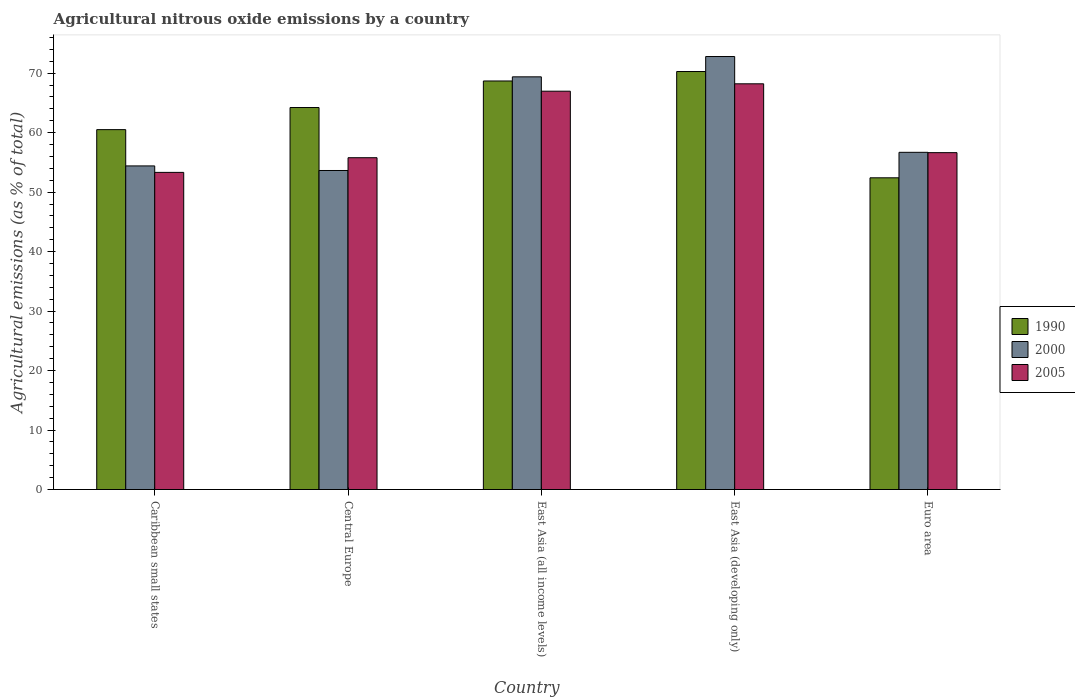How many different coloured bars are there?
Give a very brief answer. 3. Are the number of bars on each tick of the X-axis equal?
Keep it short and to the point. Yes. How many bars are there on the 5th tick from the left?
Give a very brief answer. 3. How many bars are there on the 5th tick from the right?
Give a very brief answer. 3. What is the label of the 2nd group of bars from the left?
Provide a short and direct response. Central Europe. What is the amount of agricultural nitrous oxide emitted in 2000 in East Asia (developing only)?
Your answer should be compact. 72.8. Across all countries, what is the maximum amount of agricultural nitrous oxide emitted in 1990?
Offer a terse response. 70.28. Across all countries, what is the minimum amount of agricultural nitrous oxide emitted in 2000?
Offer a very short reply. 53.64. In which country was the amount of agricultural nitrous oxide emitted in 2000 maximum?
Your response must be concise. East Asia (developing only). In which country was the amount of agricultural nitrous oxide emitted in 2005 minimum?
Make the answer very short. Caribbean small states. What is the total amount of agricultural nitrous oxide emitted in 2000 in the graph?
Your answer should be very brief. 306.92. What is the difference between the amount of agricultural nitrous oxide emitted in 2000 in Caribbean small states and that in Euro area?
Your answer should be compact. -2.28. What is the difference between the amount of agricultural nitrous oxide emitted in 1990 in East Asia (developing only) and the amount of agricultural nitrous oxide emitted in 2005 in Euro area?
Your answer should be very brief. 13.64. What is the average amount of agricultural nitrous oxide emitted in 2000 per country?
Offer a terse response. 61.38. What is the difference between the amount of agricultural nitrous oxide emitted of/in 1990 and amount of agricultural nitrous oxide emitted of/in 2005 in Caribbean small states?
Your answer should be very brief. 7.19. What is the ratio of the amount of agricultural nitrous oxide emitted in 2000 in Central Europe to that in East Asia (developing only)?
Your answer should be compact. 0.74. What is the difference between the highest and the second highest amount of agricultural nitrous oxide emitted in 2005?
Provide a succinct answer. -10.33. What is the difference between the highest and the lowest amount of agricultural nitrous oxide emitted in 2005?
Provide a succinct answer. 14.89. In how many countries, is the amount of agricultural nitrous oxide emitted in 2000 greater than the average amount of agricultural nitrous oxide emitted in 2000 taken over all countries?
Your answer should be very brief. 2. Is the sum of the amount of agricultural nitrous oxide emitted in 2000 in Central Europe and East Asia (all income levels) greater than the maximum amount of agricultural nitrous oxide emitted in 2005 across all countries?
Your answer should be compact. Yes. What does the 2nd bar from the left in East Asia (developing only) represents?
Your answer should be compact. 2000. Is it the case that in every country, the sum of the amount of agricultural nitrous oxide emitted in 2005 and amount of agricultural nitrous oxide emitted in 1990 is greater than the amount of agricultural nitrous oxide emitted in 2000?
Provide a succinct answer. Yes. How many countries are there in the graph?
Keep it short and to the point. 5. What is the title of the graph?
Offer a terse response. Agricultural nitrous oxide emissions by a country. What is the label or title of the X-axis?
Your response must be concise. Country. What is the label or title of the Y-axis?
Offer a terse response. Agricultural emissions (as % of total). What is the Agricultural emissions (as % of total) in 1990 in Caribbean small states?
Make the answer very short. 60.51. What is the Agricultural emissions (as % of total) of 2000 in Caribbean small states?
Ensure brevity in your answer.  54.41. What is the Agricultural emissions (as % of total) in 2005 in Caribbean small states?
Give a very brief answer. 53.32. What is the Agricultural emissions (as % of total) in 1990 in Central Europe?
Offer a very short reply. 64.23. What is the Agricultural emissions (as % of total) in 2000 in Central Europe?
Ensure brevity in your answer.  53.64. What is the Agricultural emissions (as % of total) of 2005 in Central Europe?
Make the answer very short. 55.79. What is the Agricultural emissions (as % of total) of 1990 in East Asia (all income levels)?
Make the answer very short. 68.69. What is the Agricultural emissions (as % of total) in 2000 in East Asia (all income levels)?
Your answer should be very brief. 69.38. What is the Agricultural emissions (as % of total) of 2005 in East Asia (all income levels)?
Provide a succinct answer. 66.97. What is the Agricultural emissions (as % of total) in 1990 in East Asia (developing only)?
Make the answer very short. 70.28. What is the Agricultural emissions (as % of total) of 2000 in East Asia (developing only)?
Your response must be concise. 72.8. What is the Agricultural emissions (as % of total) in 2005 in East Asia (developing only)?
Your response must be concise. 68.21. What is the Agricultural emissions (as % of total) of 1990 in Euro area?
Your response must be concise. 52.41. What is the Agricultural emissions (as % of total) of 2000 in Euro area?
Give a very brief answer. 56.69. What is the Agricultural emissions (as % of total) in 2005 in Euro area?
Your answer should be very brief. 56.64. Across all countries, what is the maximum Agricultural emissions (as % of total) of 1990?
Offer a very short reply. 70.28. Across all countries, what is the maximum Agricultural emissions (as % of total) in 2000?
Offer a terse response. 72.8. Across all countries, what is the maximum Agricultural emissions (as % of total) in 2005?
Make the answer very short. 68.21. Across all countries, what is the minimum Agricultural emissions (as % of total) of 1990?
Your response must be concise. 52.41. Across all countries, what is the minimum Agricultural emissions (as % of total) of 2000?
Make the answer very short. 53.64. Across all countries, what is the minimum Agricultural emissions (as % of total) in 2005?
Ensure brevity in your answer.  53.32. What is the total Agricultural emissions (as % of total) of 1990 in the graph?
Give a very brief answer. 316.1. What is the total Agricultural emissions (as % of total) of 2000 in the graph?
Offer a very short reply. 306.92. What is the total Agricultural emissions (as % of total) of 2005 in the graph?
Offer a terse response. 300.92. What is the difference between the Agricultural emissions (as % of total) in 1990 in Caribbean small states and that in Central Europe?
Your answer should be very brief. -3.72. What is the difference between the Agricultural emissions (as % of total) of 2000 in Caribbean small states and that in Central Europe?
Ensure brevity in your answer.  0.77. What is the difference between the Agricultural emissions (as % of total) of 2005 in Caribbean small states and that in Central Europe?
Ensure brevity in your answer.  -2.47. What is the difference between the Agricultural emissions (as % of total) of 1990 in Caribbean small states and that in East Asia (all income levels)?
Give a very brief answer. -8.18. What is the difference between the Agricultural emissions (as % of total) in 2000 in Caribbean small states and that in East Asia (all income levels)?
Your answer should be compact. -14.97. What is the difference between the Agricultural emissions (as % of total) in 2005 in Caribbean small states and that in East Asia (all income levels)?
Your answer should be very brief. -13.65. What is the difference between the Agricultural emissions (as % of total) of 1990 in Caribbean small states and that in East Asia (developing only)?
Your response must be concise. -9.77. What is the difference between the Agricultural emissions (as % of total) in 2000 in Caribbean small states and that in East Asia (developing only)?
Your answer should be very brief. -18.39. What is the difference between the Agricultural emissions (as % of total) of 2005 in Caribbean small states and that in East Asia (developing only)?
Your response must be concise. -14.89. What is the difference between the Agricultural emissions (as % of total) in 1990 in Caribbean small states and that in Euro area?
Keep it short and to the point. 8.1. What is the difference between the Agricultural emissions (as % of total) in 2000 in Caribbean small states and that in Euro area?
Offer a very short reply. -2.28. What is the difference between the Agricultural emissions (as % of total) in 2005 in Caribbean small states and that in Euro area?
Ensure brevity in your answer.  -3.32. What is the difference between the Agricultural emissions (as % of total) of 1990 in Central Europe and that in East Asia (all income levels)?
Provide a succinct answer. -4.46. What is the difference between the Agricultural emissions (as % of total) in 2000 in Central Europe and that in East Asia (all income levels)?
Provide a short and direct response. -15.75. What is the difference between the Agricultural emissions (as % of total) in 2005 in Central Europe and that in East Asia (all income levels)?
Provide a short and direct response. -11.18. What is the difference between the Agricultural emissions (as % of total) of 1990 in Central Europe and that in East Asia (developing only)?
Offer a terse response. -6.05. What is the difference between the Agricultural emissions (as % of total) in 2000 in Central Europe and that in East Asia (developing only)?
Offer a terse response. -19.16. What is the difference between the Agricultural emissions (as % of total) of 2005 in Central Europe and that in East Asia (developing only)?
Your response must be concise. -12.43. What is the difference between the Agricultural emissions (as % of total) of 1990 in Central Europe and that in Euro area?
Offer a very short reply. 11.82. What is the difference between the Agricultural emissions (as % of total) of 2000 in Central Europe and that in Euro area?
Your response must be concise. -3.06. What is the difference between the Agricultural emissions (as % of total) of 2005 in Central Europe and that in Euro area?
Provide a short and direct response. -0.85. What is the difference between the Agricultural emissions (as % of total) in 1990 in East Asia (all income levels) and that in East Asia (developing only)?
Provide a short and direct response. -1.59. What is the difference between the Agricultural emissions (as % of total) of 2000 in East Asia (all income levels) and that in East Asia (developing only)?
Provide a succinct answer. -3.42. What is the difference between the Agricultural emissions (as % of total) of 2005 in East Asia (all income levels) and that in East Asia (developing only)?
Your answer should be very brief. -1.24. What is the difference between the Agricultural emissions (as % of total) of 1990 in East Asia (all income levels) and that in Euro area?
Give a very brief answer. 16.28. What is the difference between the Agricultural emissions (as % of total) of 2000 in East Asia (all income levels) and that in Euro area?
Provide a succinct answer. 12.69. What is the difference between the Agricultural emissions (as % of total) in 2005 in East Asia (all income levels) and that in Euro area?
Offer a very short reply. 10.33. What is the difference between the Agricultural emissions (as % of total) of 1990 in East Asia (developing only) and that in Euro area?
Your answer should be very brief. 17.87. What is the difference between the Agricultural emissions (as % of total) in 2000 in East Asia (developing only) and that in Euro area?
Give a very brief answer. 16.11. What is the difference between the Agricultural emissions (as % of total) in 2005 in East Asia (developing only) and that in Euro area?
Keep it short and to the point. 11.57. What is the difference between the Agricultural emissions (as % of total) of 1990 in Caribbean small states and the Agricultural emissions (as % of total) of 2000 in Central Europe?
Provide a succinct answer. 6.87. What is the difference between the Agricultural emissions (as % of total) of 1990 in Caribbean small states and the Agricultural emissions (as % of total) of 2005 in Central Europe?
Make the answer very short. 4.72. What is the difference between the Agricultural emissions (as % of total) in 2000 in Caribbean small states and the Agricultural emissions (as % of total) in 2005 in Central Europe?
Your answer should be compact. -1.38. What is the difference between the Agricultural emissions (as % of total) of 1990 in Caribbean small states and the Agricultural emissions (as % of total) of 2000 in East Asia (all income levels)?
Provide a short and direct response. -8.88. What is the difference between the Agricultural emissions (as % of total) in 1990 in Caribbean small states and the Agricultural emissions (as % of total) in 2005 in East Asia (all income levels)?
Make the answer very short. -6.46. What is the difference between the Agricultural emissions (as % of total) of 2000 in Caribbean small states and the Agricultural emissions (as % of total) of 2005 in East Asia (all income levels)?
Offer a very short reply. -12.56. What is the difference between the Agricultural emissions (as % of total) of 1990 in Caribbean small states and the Agricultural emissions (as % of total) of 2000 in East Asia (developing only)?
Offer a very short reply. -12.29. What is the difference between the Agricultural emissions (as % of total) of 1990 in Caribbean small states and the Agricultural emissions (as % of total) of 2005 in East Asia (developing only)?
Your answer should be compact. -7.71. What is the difference between the Agricultural emissions (as % of total) in 2000 in Caribbean small states and the Agricultural emissions (as % of total) in 2005 in East Asia (developing only)?
Your answer should be compact. -13.8. What is the difference between the Agricultural emissions (as % of total) in 1990 in Caribbean small states and the Agricultural emissions (as % of total) in 2000 in Euro area?
Your answer should be compact. 3.81. What is the difference between the Agricultural emissions (as % of total) in 1990 in Caribbean small states and the Agricultural emissions (as % of total) in 2005 in Euro area?
Offer a very short reply. 3.87. What is the difference between the Agricultural emissions (as % of total) in 2000 in Caribbean small states and the Agricultural emissions (as % of total) in 2005 in Euro area?
Offer a very short reply. -2.23. What is the difference between the Agricultural emissions (as % of total) of 1990 in Central Europe and the Agricultural emissions (as % of total) of 2000 in East Asia (all income levels)?
Ensure brevity in your answer.  -5.16. What is the difference between the Agricultural emissions (as % of total) of 1990 in Central Europe and the Agricultural emissions (as % of total) of 2005 in East Asia (all income levels)?
Offer a very short reply. -2.74. What is the difference between the Agricultural emissions (as % of total) of 2000 in Central Europe and the Agricultural emissions (as % of total) of 2005 in East Asia (all income levels)?
Offer a terse response. -13.33. What is the difference between the Agricultural emissions (as % of total) of 1990 in Central Europe and the Agricultural emissions (as % of total) of 2000 in East Asia (developing only)?
Keep it short and to the point. -8.57. What is the difference between the Agricultural emissions (as % of total) in 1990 in Central Europe and the Agricultural emissions (as % of total) in 2005 in East Asia (developing only)?
Your response must be concise. -3.99. What is the difference between the Agricultural emissions (as % of total) of 2000 in Central Europe and the Agricultural emissions (as % of total) of 2005 in East Asia (developing only)?
Make the answer very short. -14.57. What is the difference between the Agricultural emissions (as % of total) in 1990 in Central Europe and the Agricultural emissions (as % of total) in 2000 in Euro area?
Offer a terse response. 7.53. What is the difference between the Agricultural emissions (as % of total) of 1990 in Central Europe and the Agricultural emissions (as % of total) of 2005 in Euro area?
Provide a short and direct response. 7.59. What is the difference between the Agricultural emissions (as % of total) in 2000 in Central Europe and the Agricultural emissions (as % of total) in 2005 in Euro area?
Your answer should be very brief. -3. What is the difference between the Agricultural emissions (as % of total) in 1990 in East Asia (all income levels) and the Agricultural emissions (as % of total) in 2000 in East Asia (developing only)?
Provide a succinct answer. -4.11. What is the difference between the Agricultural emissions (as % of total) of 1990 in East Asia (all income levels) and the Agricultural emissions (as % of total) of 2005 in East Asia (developing only)?
Offer a very short reply. 0.48. What is the difference between the Agricultural emissions (as % of total) of 2000 in East Asia (all income levels) and the Agricultural emissions (as % of total) of 2005 in East Asia (developing only)?
Give a very brief answer. 1.17. What is the difference between the Agricultural emissions (as % of total) of 1990 in East Asia (all income levels) and the Agricultural emissions (as % of total) of 2000 in Euro area?
Provide a short and direct response. 11.99. What is the difference between the Agricultural emissions (as % of total) of 1990 in East Asia (all income levels) and the Agricultural emissions (as % of total) of 2005 in Euro area?
Make the answer very short. 12.05. What is the difference between the Agricultural emissions (as % of total) of 2000 in East Asia (all income levels) and the Agricultural emissions (as % of total) of 2005 in Euro area?
Your answer should be compact. 12.74. What is the difference between the Agricultural emissions (as % of total) in 1990 in East Asia (developing only) and the Agricultural emissions (as % of total) in 2000 in Euro area?
Your response must be concise. 13.58. What is the difference between the Agricultural emissions (as % of total) in 1990 in East Asia (developing only) and the Agricultural emissions (as % of total) in 2005 in Euro area?
Provide a succinct answer. 13.64. What is the difference between the Agricultural emissions (as % of total) of 2000 in East Asia (developing only) and the Agricultural emissions (as % of total) of 2005 in Euro area?
Your answer should be very brief. 16.16. What is the average Agricultural emissions (as % of total) in 1990 per country?
Keep it short and to the point. 63.22. What is the average Agricultural emissions (as % of total) in 2000 per country?
Your answer should be compact. 61.38. What is the average Agricultural emissions (as % of total) in 2005 per country?
Ensure brevity in your answer.  60.18. What is the difference between the Agricultural emissions (as % of total) of 1990 and Agricultural emissions (as % of total) of 2000 in Caribbean small states?
Your answer should be very brief. 6.1. What is the difference between the Agricultural emissions (as % of total) in 1990 and Agricultural emissions (as % of total) in 2005 in Caribbean small states?
Offer a terse response. 7.19. What is the difference between the Agricultural emissions (as % of total) of 2000 and Agricultural emissions (as % of total) of 2005 in Caribbean small states?
Your answer should be very brief. 1.09. What is the difference between the Agricultural emissions (as % of total) in 1990 and Agricultural emissions (as % of total) in 2000 in Central Europe?
Provide a short and direct response. 10.59. What is the difference between the Agricultural emissions (as % of total) in 1990 and Agricultural emissions (as % of total) in 2005 in Central Europe?
Your answer should be compact. 8.44. What is the difference between the Agricultural emissions (as % of total) in 2000 and Agricultural emissions (as % of total) in 2005 in Central Europe?
Your answer should be compact. -2.15. What is the difference between the Agricultural emissions (as % of total) of 1990 and Agricultural emissions (as % of total) of 2000 in East Asia (all income levels)?
Ensure brevity in your answer.  -0.7. What is the difference between the Agricultural emissions (as % of total) of 1990 and Agricultural emissions (as % of total) of 2005 in East Asia (all income levels)?
Your answer should be very brief. 1.72. What is the difference between the Agricultural emissions (as % of total) in 2000 and Agricultural emissions (as % of total) in 2005 in East Asia (all income levels)?
Keep it short and to the point. 2.41. What is the difference between the Agricultural emissions (as % of total) of 1990 and Agricultural emissions (as % of total) of 2000 in East Asia (developing only)?
Your answer should be very brief. -2.52. What is the difference between the Agricultural emissions (as % of total) of 1990 and Agricultural emissions (as % of total) of 2005 in East Asia (developing only)?
Keep it short and to the point. 2.07. What is the difference between the Agricultural emissions (as % of total) of 2000 and Agricultural emissions (as % of total) of 2005 in East Asia (developing only)?
Offer a very short reply. 4.59. What is the difference between the Agricultural emissions (as % of total) of 1990 and Agricultural emissions (as % of total) of 2000 in Euro area?
Give a very brief answer. -4.28. What is the difference between the Agricultural emissions (as % of total) of 1990 and Agricultural emissions (as % of total) of 2005 in Euro area?
Keep it short and to the point. -4.23. What is the difference between the Agricultural emissions (as % of total) in 2000 and Agricultural emissions (as % of total) in 2005 in Euro area?
Ensure brevity in your answer.  0.05. What is the ratio of the Agricultural emissions (as % of total) of 1990 in Caribbean small states to that in Central Europe?
Ensure brevity in your answer.  0.94. What is the ratio of the Agricultural emissions (as % of total) in 2000 in Caribbean small states to that in Central Europe?
Make the answer very short. 1.01. What is the ratio of the Agricultural emissions (as % of total) of 2005 in Caribbean small states to that in Central Europe?
Your answer should be very brief. 0.96. What is the ratio of the Agricultural emissions (as % of total) of 1990 in Caribbean small states to that in East Asia (all income levels)?
Provide a succinct answer. 0.88. What is the ratio of the Agricultural emissions (as % of total) of 2000 in Caribbean small states to that in East Asia (all income levels)?
Offer a very short reply. 0.78. What is the ratio of the Agricultural emissions (as % of total) of 2005 in Caribbean small states to that in East Asia (all income levels)?
Your answer should be very brief. 0.8. What is the ratio of the Agricultural emissions (as % of total) in 1990 in Caribbean small states to that in East Asia (developing only)?
Make the answer very short. 0.86. What is the ratio of the Agricultural emissions (as % of total) of 2000 in Caribbean small states to that in East Asia (developing only)?
Your answer should be compact. 0.75. What is the ratio of the Agricultural emissions (as % of total) of 2005 in Caribbean small states to that in East Asia (developing only)?
Ensure brevity in your answer.  0.78. What is the ratio of the Agricultural emissions (as % of total) of 1990 in Caribbean small states to that in Euro area?
Your answer should be very brief. 1.15. What is the ratio of the Agricultural emissions (as % of total) of 2000 in Caribbean small states to that in Euro area?
Offer a terse response. 0.96. What is the ratio of the Agricultural emissions (as % of total) in 2005 in Caribbean small states to that in Euro area?
Keep it short and to the point. 0.94. What is the ratio of the Agricultural emissions (as % of total) in 1990 in Central Europe to that in East Asia (all income levels)?
Give a very brief answer. 0.94. What is the ratio of the Agricultural emissions (as % of total) in 2000 in Central Europe to that in East Asia (all income levels)?
Your answer should be very brief. 0.77. What is the ratio of the Agricultural emissions (as % of total) of 2005 in Central Europe to that in East Asia (all income levels)?
Keep it short and to the point. 0.83. What is the ratio of the Agricultural emissions (as % of total) in 1990 in Central Europe to that in East Asia (developing only)?
Make the answer very short. 0.91. What is the ratio of the Agricultural emissions (as % of total) in 2000 in Central Europe to that in East Asia (developing only)?
Your response must be concise. 0.74. What is the ratio of the Agricultural emissions (as % of total) in 2005 in Central Europe to that in East Asia (developing only)?
Offer a terse response. 0.82. What is the ratio of the Agricultural emissions (as % of total) in 1990 in Central Europe to that in Euro area?
Give a very brief answer. 1.23. What is the ratio of the Agricultural emissions (as % of total) in 2000 in Central Europe to that in Euro area?
Provide a short and direct response. 0.95. What is the ratio of the Agricultural emissions (as % of total) in 2005 in Central Europe to that in Euro area?
Give a very brief answer. 0.98. What is the ratio of the Agricultural emissions (as % of total) of 1990 in East Asia (all income levels) to that in East Asia (developing only)?
Give a very brief answer. 0.98. What is the ratio of the Agricultural emissions (as % of total) of 2000 in East Asia (all income levels) to that in East Asia (developing only)?
Provide a succinct answer. 0.95. What is the ratio of the Agricultural emissions (as % of total) in 2005 in East Asia (all income levels) to that in East Asia (developing only)?
Provide a short and direct response. 0.98. What is the ratio of the Agricultural emissions (as % of total) in 1990 in East Asia (all income levels) to that in Euro area?
Give a very brief answer. 1.31. What is the ratio of the Agricultural emissions (as % of total) of 2000 in East Asia (all income levels) to that in Euro area?
Offer a very short reply. 1.22. What is the ratio of the Agricultural emissions (as % of total) of 2005 in East Asia (all income levels) to that in Euro area?
Give a very brief answer. 1.18. What is the ratio of the Agricultural emissions (as % of total) in 1990 in East Asia (developing only) to that in Euro area?
Offer a very short reply. 1.34. What is the ratio of the Agricultural emissions (as % of total) in 2000 in East Asia (developing only) to that in Euro area?
Your answer should be compact. 1.28. What is the ratio of the Agricultural emissions (as % of total) in 2005 in East Asia (developing only) to that in Euro area?
Your answer should be very brief. 1.2. What is the difference between the highest and the second highest Agricultural emissions (as % of total) in 1990?
Offer a very short reply. 1.59. What is the difference between the highest and the second highest Agricultural emissions (as % of total) of 2000?
Keep it short and to the point. 3.42. What is the difference between the highest and the second highest Agricultural emissions (as % of total) of 2005?
Ensure brevity in your answer.  1.24. What is the difference between the highest and the lowest Agricultural emissions (as % of total) of 1990?
Provide a succinct answer. 17.87. What is the difference between the highest and the lowest Agricultural emissions (as % of total) of 2000?
Your response must be concise. 19.16. What is the difference between the highest and the lowest Agricultural emissions (as % of total) of 2005?
Offer a very short reply. 14.89. 